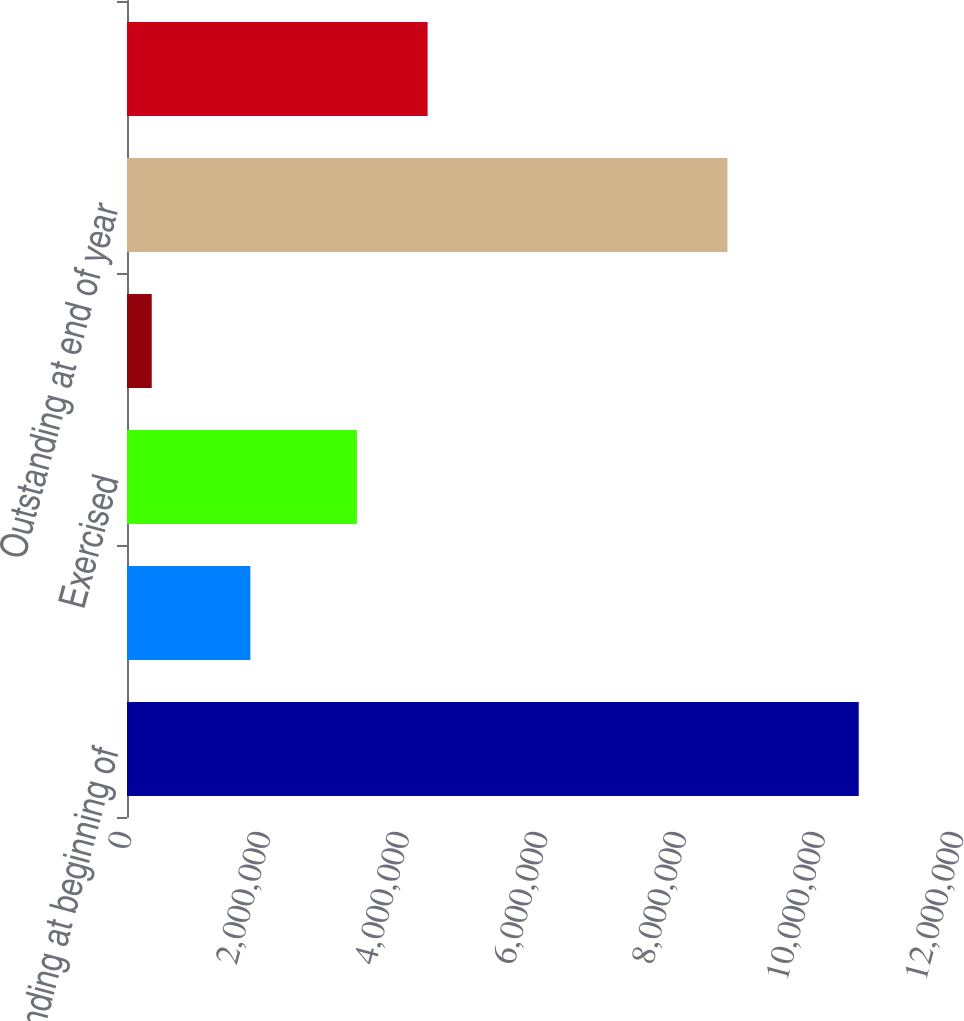Convert chart to OTSL. <chart><loc_0><loc_0><loc_500><loc_500><bar_chart><fcel>Outstanding at beginning of<fcel>Granted<fcel>Exercised<fcel>Forfeited<fcel>Outstanding at end of year<fcel>Options exercisable at<nl><fcel>1.05539e+07<fcel>1.77911e+06<fcel>3.31599e+06<fcel>356697<fcel>8.66034e+06<fcel>4.33571e+06<nl></chart> 